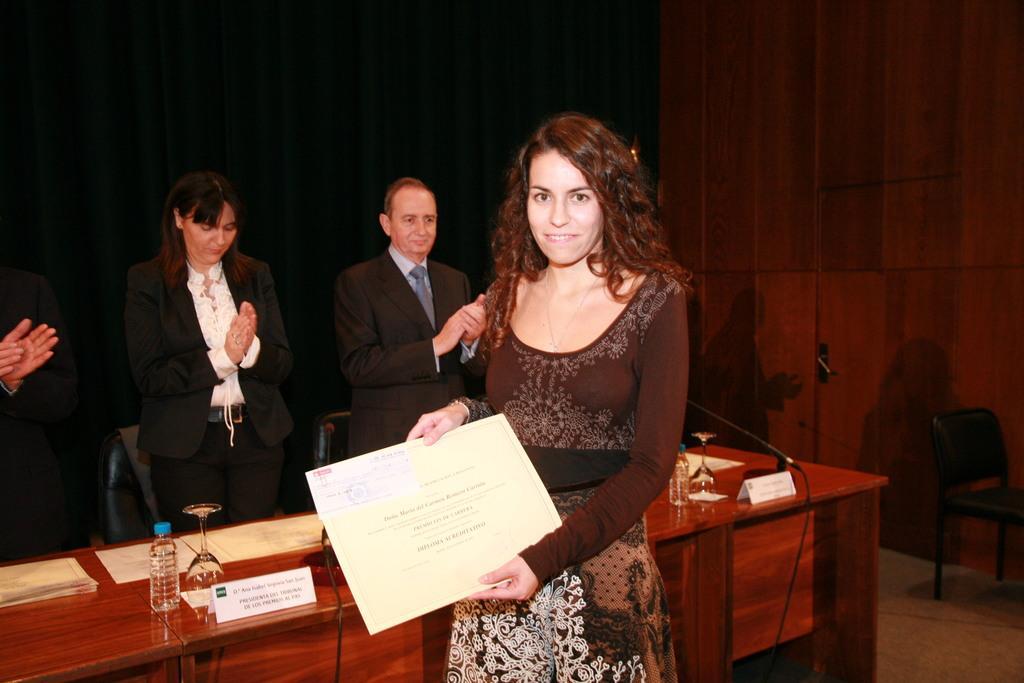Please provide a concise description of this image. In this image there is a lady standing on a floor holding a certificate in her hand, in the background there is a table on that table there are bottles, glasses, papers, behind the table there are people standing and there are chairs, in the background it is dark. 